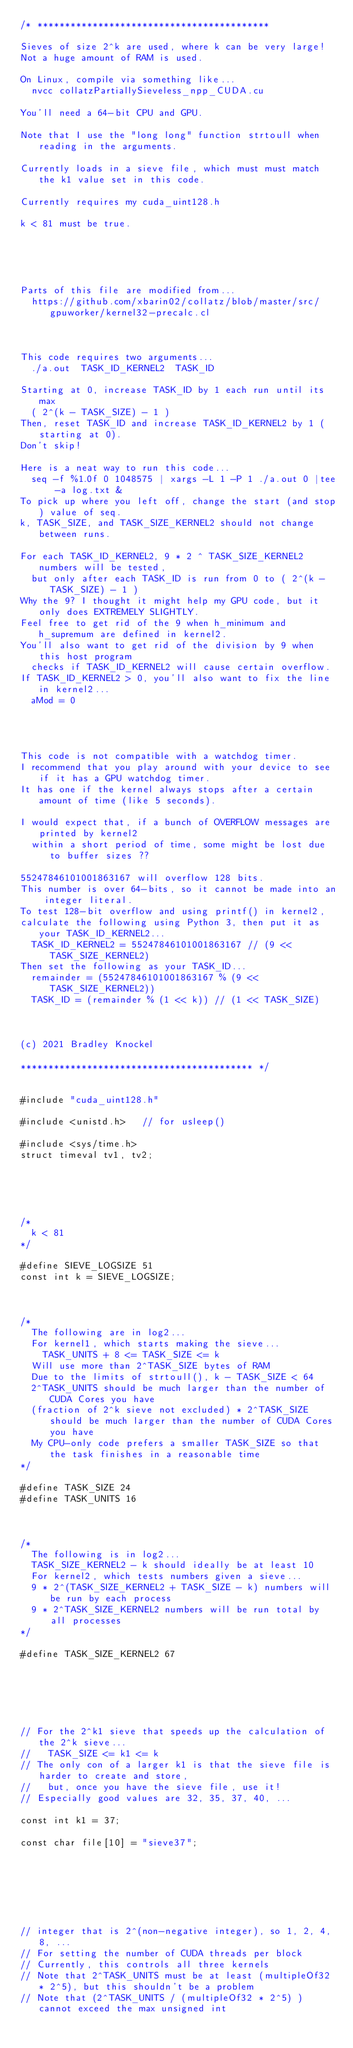<code> <loc_0><loc_0><loc_500><loc_500><_Cuda_>/* ******************************************

Sieves of size 2^k are used, where k can be very large!
Not a huge amount of RAM is used.

On Linux, compile via something like...
  nvcc collatzPartiallySieveless_npp_CUDA.cu

You'll need a 64-bit CPU and GPU.

Note that I use the "long long" function strtoull when reading in the arguments.

Currently loads in a sieve file, which must must match the k1 value set in this code.

Currently requires my cuda_uint128.h

k < 81 must be true.





Parts of this file are modified from...
  https://github.com/xbarin02/collatz/blob/master/src/gpuworker/kernel32-precalc.cl



This code requires two arguments...
  ./a.out  TASK_ID_KERNEL2  TASK_ID

Starting at 0, increase TASK_ID by 1 each run until its max
  ( 2^(k - TASK_SIZE) - 1 )
Then, reset TASK_ID and increase TASK_ID_KERNEL2 by 1 (starting at 0).
Don't skip!

Here is a neat way to run this code...
  seq -f %1.0f 0 1048575 | xargs -L 1 -P 1 ./a.out 0 |tee -a log.txt &
To pick up where you left off, change the start (and stop) value of seq.
k, TASK_SIZE, and TASK_SIZE_KERNEL2 should not change between runs.

For each TASK_ID_KERNEL2, 9 * 2 ^ TASK_SIZE_KERNEL2 numbers will be tested,
  but only after each TASK_ID is run from 0 to ( 2^(k - TASK_SIZE) - 1 )
Why the 9? I thought it might help my GPU code, but it only does EXTREMELY SLIGHTLY.
Feel free to get rid of the 9 when h_minimum and h_supremum are defined in kernel2.
You'll also want to get rid of the division by 9 when this host program
  checks if TASK_ID_KERNEL2 will cause certain overflow.
If TASK_ID_KERNEL2 > 0, you'll also want to fix the line in kernel2...
  aMod = 0




This code is not compatible with a watchdog timer.
I recommend that you play around with your device to see if it has a GPU watchdog timer.
It has one if the kernel always stops after a certain amount of time (like 5 seconds).

I would expect that, if a bunch of OVERFLOW messages are printed by kernel2
  within a short period of time, some might be lost due to buffer sizes ??

55247846101001863167 will overflow 128 bits.
This number is over 64-bits, so it cannot be made into an integer literal.
To test 128-bit overflow and using printf() in kernel2,
calculate the following using Python 3, then put it as your TASK_ID_KERNEL2...
  TASK_ID_KERNEL2 = 55247846101001863167 // (9 << TASK_SIZE_KERNEL2)
Then set the following as your TASK_ID...
  remainder = (55247846101001863167 % (9 << TASK_SIZE_KERNEL2))
  TASK_ID = (remainder % (1 << k)) // (1 << TASK_SIZE)



(c) 2021 Bradley Knockel

****************************************** */


#include "cuda_uint128.h"

#include <unistd.h>   // for usleep()

#include <sys/time.h>
struct timeval tv1, tv2;





/*
  k < 81
*/

#define SIEVE_LOGSIZE 51
const int k = SIEVE_LOGSIZE;



/*
  The following are in log2...
  For kernel1, which starts making the sieve...
    TASK_UNITS + 8 <= TASK_SIZE <= k
  Will use more than 2^TASK_SIZE bytes of RAM
  Due to the limits of strtoull(), k - TASK_SIZE < 64
  2^TASK_UNITS should be much larger than the number of CUDA Cores you have
  (fraction of 2^k sieve not excluded) * 2^TASK_SIZE should be much larger than the number of CUDA Cores you have
  My CPU-only code prefers a smaller TASK_SIZE so that the task finishes in a reasonable time
*/

#define TASK_SIZE 24
#define TASK_UNITS 16



/*
  The following is in log2...
  TASK_SIZE_KERNEL2 - k should ideally be at least 10
  For kernel2, which tests numbers given a sieve...
  9 * 2^(TASK_SIZE_KERNEL2 + TASK_SIZE - k) numbers will be run by each process
  9 * 2^TASK_SIZE_KERNEL2 numbers will be run total by all processes
*/

#define TASK_SIZE_KERNEL2 67






// For the 2^k1 sieve that speeds up the calculation of the 2^k sieve...
//   TASK_SIZE <= k1 <= k
// The only con of a larger k1 is that the sieve file is harder to create and store,
//   but, once you have the sieve file, use it!
// Especially good values are 32, 35, 37, 40, ...

const int k1 = 37;

const char file[10] = "sieve37";







// integer that is 2^(non-negative integer), so 1, 2, 4, 8, ...
// For setting the number of CUDA threads per block
// Currently, this controls all three kernels
// Note that 2^TASK_UNITS must be at least (multipleOf32 * 2^5), but this shouldn't be a problem
// Note that (2^TASK_UNITS / (multipleOf32 * 2^5) ) cannot exceed the max unsigned int</code> 